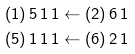<formula> <loc_0><loc_0><loc_500><loc_500>& ( 1 ) \, 5 \, 1 \, 1 \leftarrow ( 2 ) \, 6 \, 1 \\ & ( 5 ) \, 1 \, 1 \, 1 \leftarrow ( 6 ) \, 2 \, 1</formula> 